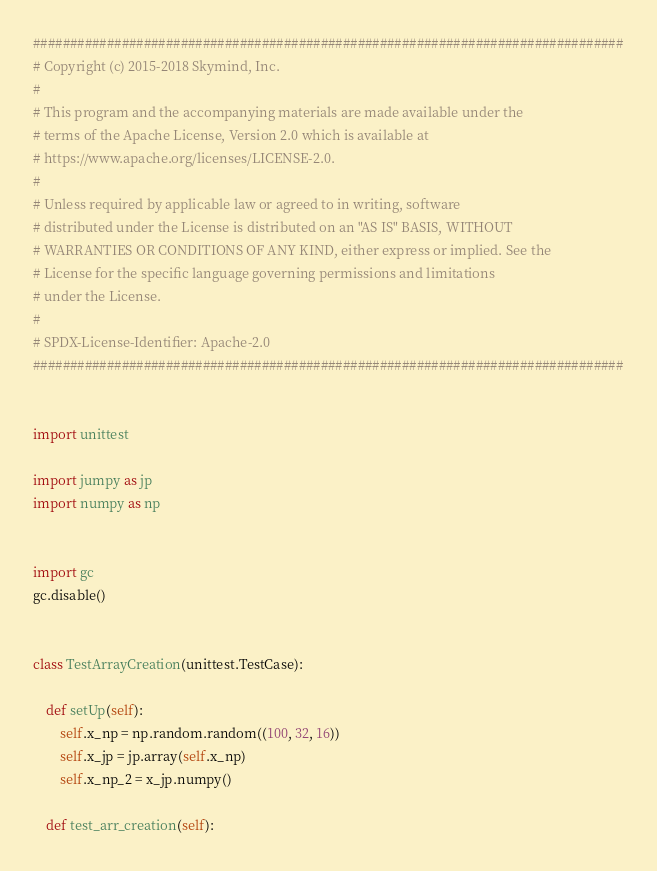<code> <loc_0><loc_0><loc_500><loc_500><_Python_>################################################################################
# Copyright (c) 2015-2018 Skymind, Inc.
#
# This program and the accompanying materials are made available under the
# terms of the Apache License, Version 2.0 which is available at
# https://www.apache.org/licenses/LICENSE-2.0.
#
# Unless required by applicable law or agreed to in writing, software
# distributed under the License is distributed on an "AS IS" BASIS, WITHOUT
# WARRANTIES OR CONDITIONS OF ANY KIND, either express or implied. See the
# License for the specific language governing permissions and limitations
# under the License.
#
# SPDX-License-Identifier: Apache-2.0
################################################################################


import unittest

import jumpy as jp
import numpy as np


import gc
gc.disable()


class TestArrayCreation(unittest.TestCase):

    def setUp(self):
        self.x_np = np.random.random((100, 32, 16))
        self.x_jp = jp.array(self.x_np)
        self.x_np_2 = x_jp.numpy()

    def test_arr_creation(self):</code> 